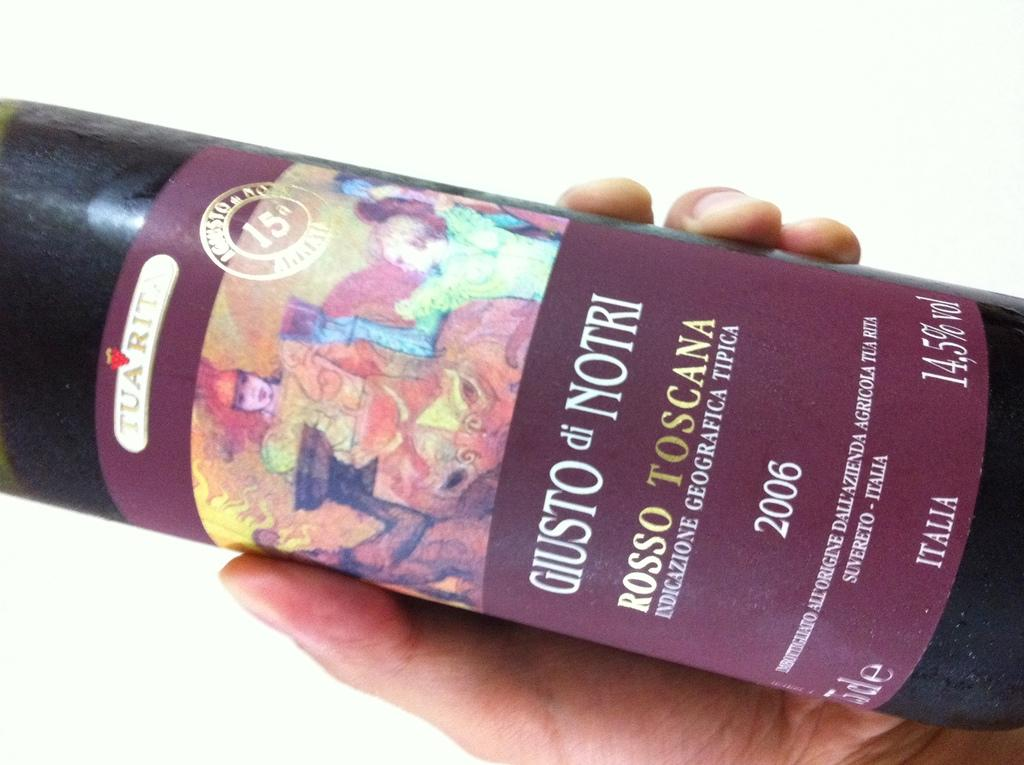<image>
Write a terse but informative summary of the picture. a bottle of Gusto di Notri in a person's hand 